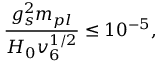Convert formula to latex. <formula><loc_0><loc_0><loc_500><loc_500>\frac { g _ { s } ^ { 2 } m _ { p l } } { H _ { 0 } v _ { 6 } ^ { 1 / 2 } } \leq 1 0 ^ { - 5 } ,</formula> 